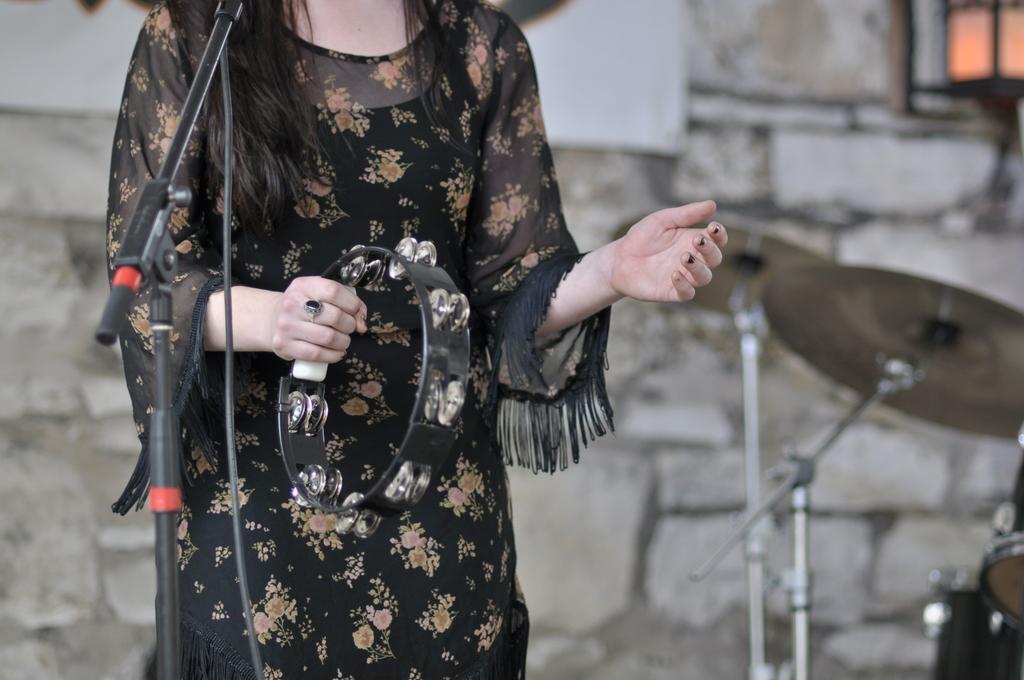Could you give a brief overview of what you see in this image? This woman is holding a musical instrument. Here we can see mic stand, cable and musical instruments. Background it is blurry and we can see a wall. 